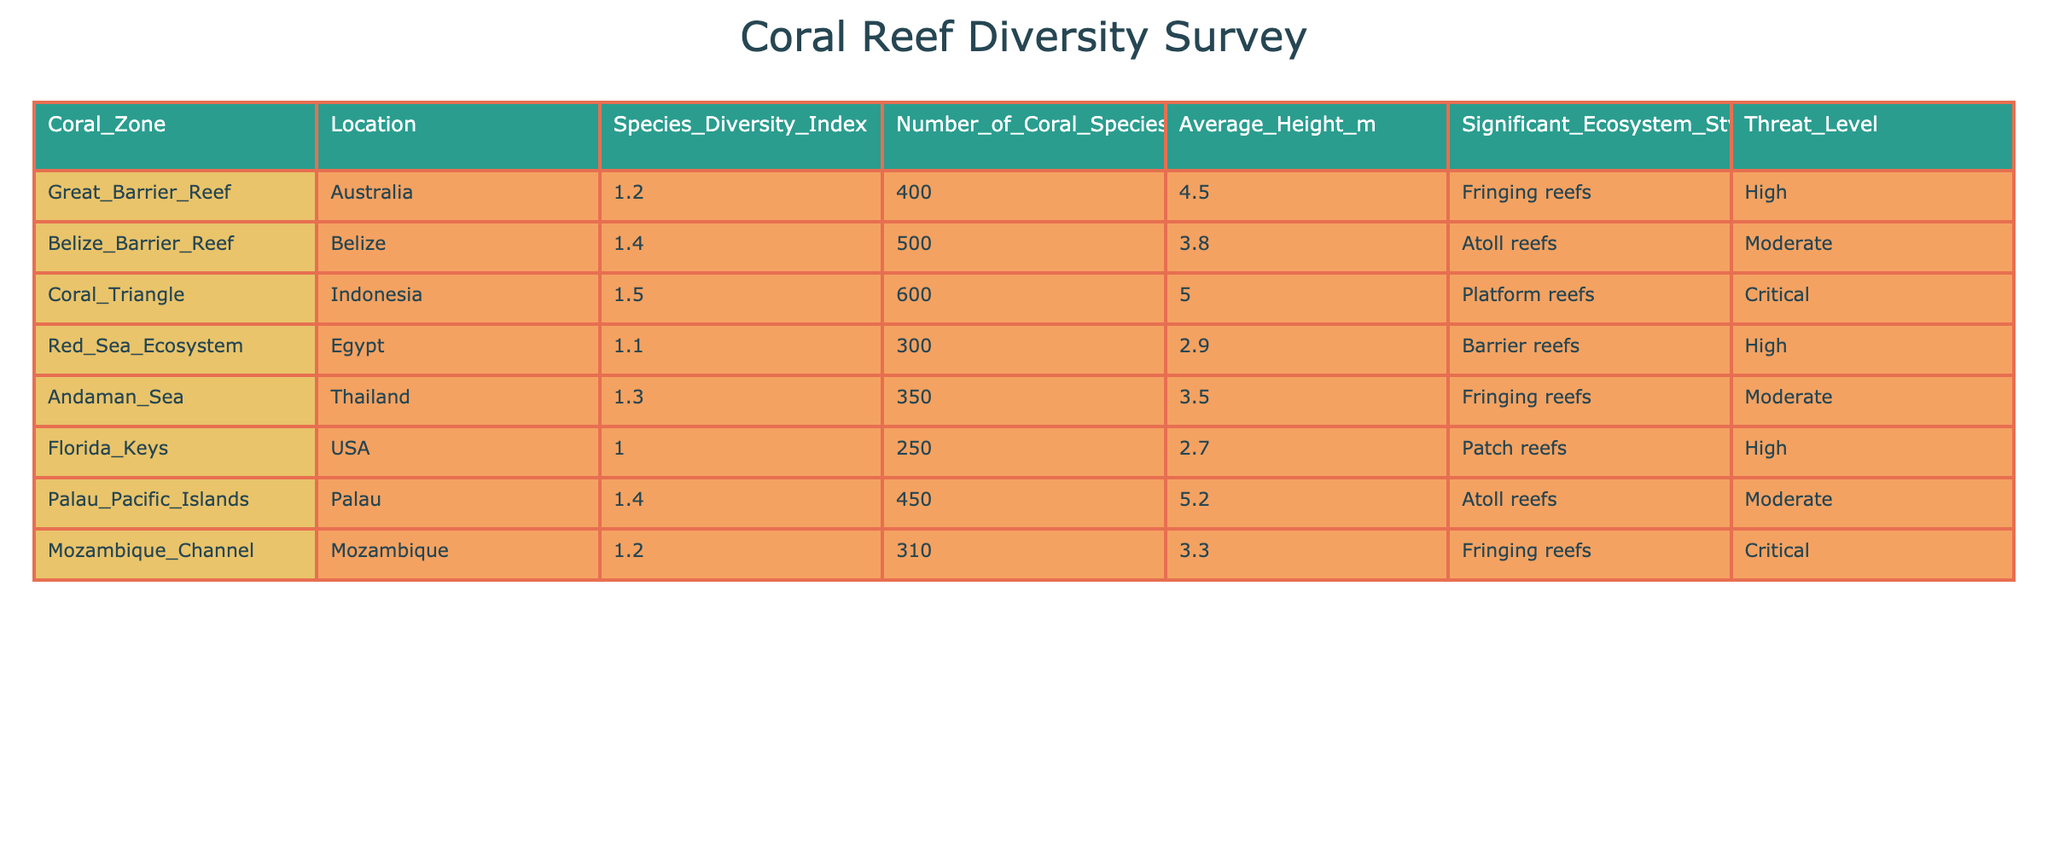What is the species diversity index of the Coral Triangle? The species diversity index for the Coral Triangle, as listed in the table, is 1.5.
Answer: 1.5 Which coral zone has the highest number of coral species? By checking the number of coral species for each zone in the table, the Coral Triangle has 600 species, which is the highest among all listed coral zones.
Answer: Coral Triangle What is the average height of the corals in the Great Barrier Reef? The average height of corals in the Great Barrier Reef is given directly in the table as 4.5 meters.
Answer: 4.5 meters Is the threat level for the Belize Barrier Reef moderate or high? Referring to the table, the threat level for the Belize Barrier Reef is categorized as moderate.
Answer: Moderate Which coral zone has the lowest average height of corals? The average heights of the corals are compared in the table, and Florida Keys has the lowest average height at 2.7 meters.
Answer: Florida Keys What is the total number of coral species found in the Red Sea Ecosystem and the Florida Keys combined? The total number of coral species can be calculated by adding together the number of species in the Red Sea Ecosystem (300) and the Florida Keys (250): 300 + 250 = 550.
Answer: 550 Are there any coral zones listed with a critical threat level? The table indicates that both the Coral Triangle and the Mozambique Channel have a critical threat level.
Answer: Yes What is the average species diversity index of the coral zones with a moderate threat level? The zones with a moderate threat level (Belize Barrier Reef, Andaman Sea, and Palau Pacific Islands) have diversity indices of 1.4, 1.3, and 1.4 respectively. The average is calculated as (1.4 + 1.3 + 1.4) / 3 = 1.3667, rounded to 1.37.
Answer: 1.37 Which of the coral zones has the highest significant ecosystem style diversity? The table shows that the Coral Triangle has one significant ecosystem style (Platform reefs), while others also show one style. Therefore, all coral zones have similar diversity in significant ecosystem styles, considering each zone has one style as listed.
Answer: All similar Does the location with the highest species diversity index also have the most coral species? By examining the table, the Coral Triangle does have the highest species diversity index (1.5) and also the highest number of coral species (600), confirming this correlation.
Answer: Yes 